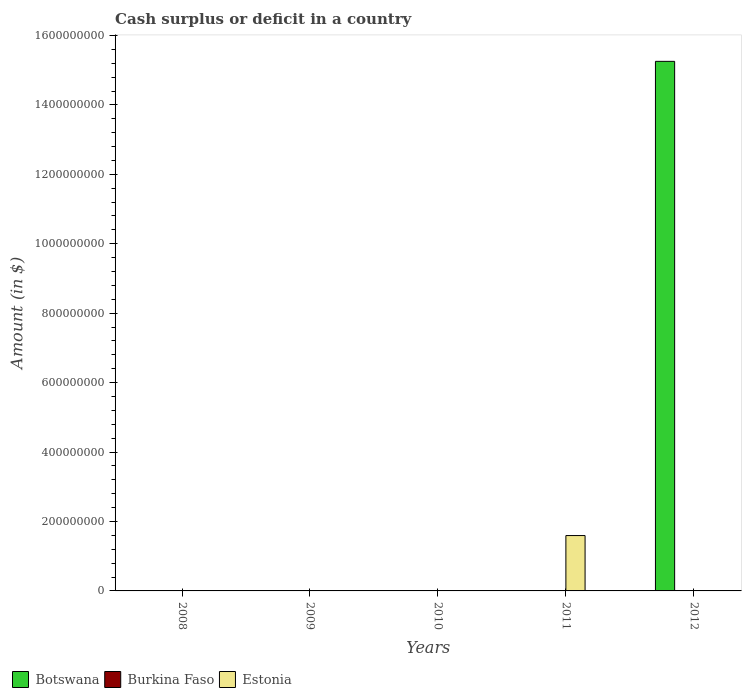How many different coloured bars are there?
Offer a very short reply. 2. Are the number of bars on each tick of the X-axis equal?
Your answer should be compact. No. How many bars are there on the 3rd tick from the right?
Provide a succinct answer. 0. In how many cases, is the number of bars for a given year not equal to the number of legend labels?
Keep it short and to the point. 5. Across all years, what is the maximum amount of cash surplus or deficit in Botswana?
Offer a very short reply. 1.53e+09. Across all years, what is the minimum amount of cash surplus or deficit in Burkina Faso?
Your answer should be compact. 0. In which year was the amount of cash surplus or deficit in Botswana maximum?
Your answer should be compact. 2012. What is the total amount of cash surplus or deficit in Estonia in the graph?
Offer a terse response. 1.60e+08. What is the average amount of cash surplus or deficit in Estonia per year?
Make the answer very short. 3.19e+07. What is the difference between the highest and the lowest amount of cash surplus or deficit in Botswana?
Offer a terse response. 1.53e+09. In how many years, is the amount of cash surplus or deficit in Burkina Faso greater than the average amount of cash surplus or deficit in Burkina Faso taken over all years?
Offer a very short reply. 0. Is it the case that in every year, the sum of the amount of cash surplus or deficit in Botswana and amount of cash surplus or deficit in Estonia is greater than the amount of cash surplus or deficit in Burkina Faso?
Offer a very short reply. No. Are the values on the major ticks of Y-axis written in scientific E-notation?
Make the answer very short. No. Does the graph contain grids?
Keep it short and to the point. No. Where does the legend appear in the graph?
Give a very brief answer. Bottom left. How are the legend labels stacked?
Your answer should be very brief. Horizontal. What is the title of the graph?
Keep it short and to the point. Cash surplus or deficit in a country. What is the label or title of the X-axis?
Give a very brief answer. Years. What is the label or title of the Y-axis?
Your answer should be very brief. Amount (in $). What is the Amount (in $) in Botswana in 2008?
Keep it short and to the point. 0. What is the Amount (in $) in Estonia in 2008?
Provide a succinct answer. 0. What is the Amount (in $) of Burkina Faso in 2009?
Ensure brevity in your answer.  0. What is the Amount (in $) of Estonia in 2009?
Keep it short and to the point. 0. What is the Amount (in $) in Botswana in 2010?
Offer a terse response. 0. What is the Amount (in $) of Estonia in 2010?
Give a very brief answer. 0. What is the Amount (in $) of Botswana in 2011?
Make the answer very short. 0. What is the Amount (in $) in Burkina Faso in 2011?
Your answer should be very brief. 0. What is the Amount (in $) of Estonia in 2011?
Provide a succinct answer. 1.60e+08. What is the Amount (in $) of Botswana in 2012?
Offer a terse response. 1.53e+09. Across all years, what is the maximum Amount (in $) in Botswana?
Keep it short and to the point. 1.53e+09. Across all years, what is the maximum Amount (in $) in Estonia?
Make the answer very short. 1.60e+08. What is the total Amount (in $) in Botswana in the graph?
Offer a terse response. 1.53e+09. What is the total Amount (in $) of Estonia in the graph?
Your answer should be compact. 1.60e+08. What is the average Amount (in $) of Botswana per year?
Ensure brevity in your answer.  3.05e+08. What is the average Amount (in $) in Estonia per year?
Keep it short and to the point. 3.19e+07. What is the difference between the highest and the lowest Amount (in $) in Botswana?
Ensure brevity in your answer.  1.53e+09. What is the difference between the highest and the lowest Amount (in $) of Estonia?
Provide a succinct answer. 1.60e+08. 